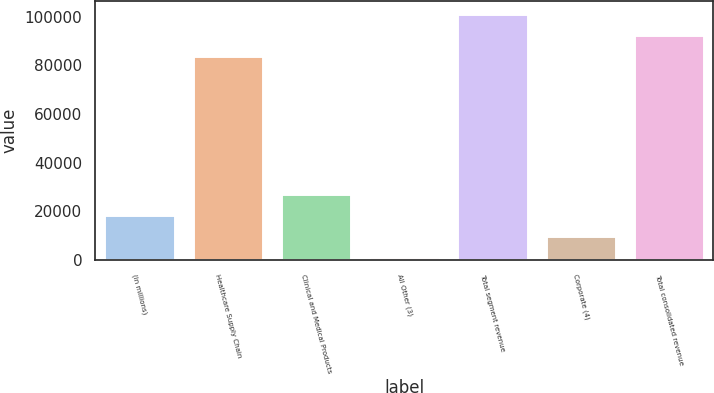<chart> <loc_0><loc_0><loc_500><loc_500><bar_chart><fcel>(in millions)<fcel>Healthcare Supply Chain<fcel>Clinical and Medical Products<fcel>All Other (3)<fcel>Total segment revenue<fcel>Corporate (4)<fcel>Total consolidated revenue<nl><fcel>18629.5<fcel>83850.7<fcel>27368.8<fcel>1151.1<fcel>101329<fcel>9890.32<fcel>92589.9<nl></chart> 